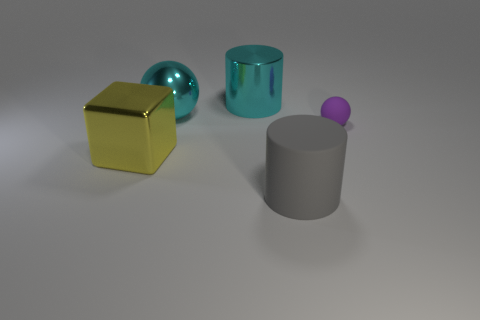Subtract all cyan cylinders. How many cylinders are left? 1 Add 2 big red cylinders. How many objects exist? 7 Subtract 1 cyan cylinders. How many objects are left? 4 Subtract all spheres. How many objects are left? 3 Subtract 2 cylinders. How many cylinders are left? 0 Subtract all gray spheres. Subtract all gray cubes. How many spheres are left? 2 Subtract all blue cylinders. How many green spheres are left? 0 Subtract all cyan metal things. Subtract all cyan metal blocks. How many objects are left? 3 Add 2 cyan spheres. How many cyan spheres are left? 3 Add 5 cyan things. How many cyan things exist? 7 